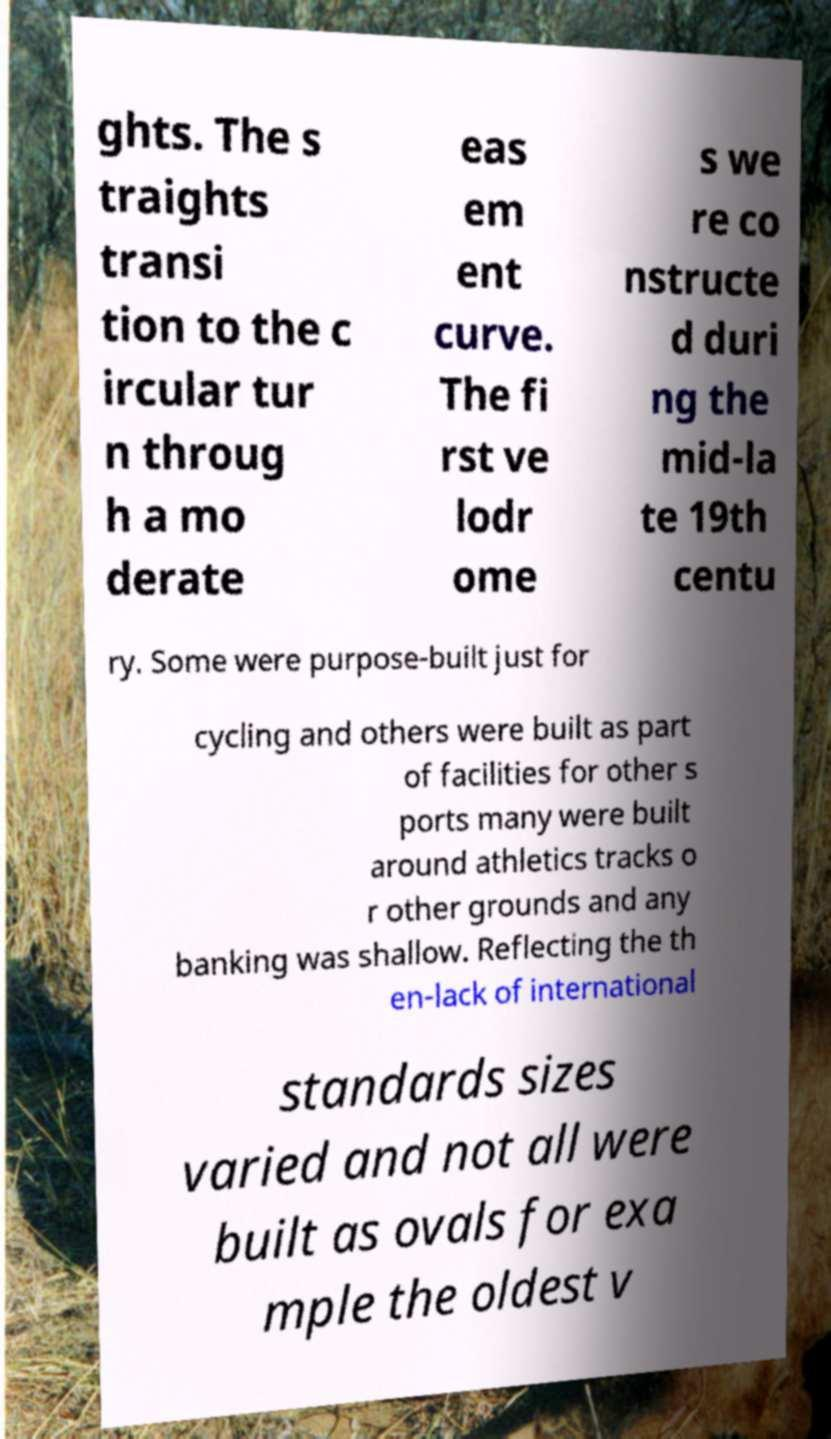I need the written content from this picture converted into text. Can you do that? ghts. The s traights transi tion to the c ircular tur n throug h a mo derate eas em ent curve. The fi rst ve lodr ome s we re co nstructe d duri ng the mid-la te 19th centu ry. Some were purpose-built just for cycling and others were built as part of facilities for other s ports many were built around athletics tracks o r other grounds and any banking was shallow. Reflecting the th en-lack of international standards sizes varied and not all were built as ovals for exa mple the oldest v 